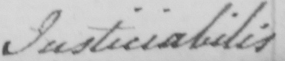Can you tell me what this handwritten text says? Justiciabilis 